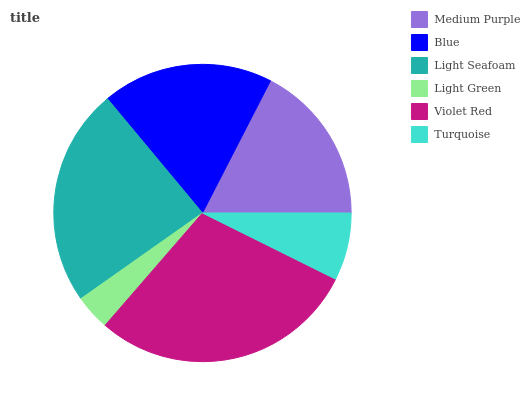Is Light Green the minimum?
Answer yes or no. Yes. Is Violet Red the maximum?
Answer yes or no. Yes. Is Blue the minimum?
Answer yes or no. No. Is Blue the maximum?
Answer yes or no. No. Is Blue greater than Medium Purple?
Answer yes or no. Yes. Is Medium Purple less than Blue?
Answer yes or no. Yes. Is Medium Purple greater than Blue?
Answer yes or no. No. Is Blue less than Medium Purple?
Answer yes or no. No. Is Blue the high median?
Answer yes or no. Yes. Is Medium Purple the low median?
Answer yes or no. Yes. Is Violet Red the high median?
Answer yes or no. No. Is Violet Red the low median?
Answer yes or no. No. 